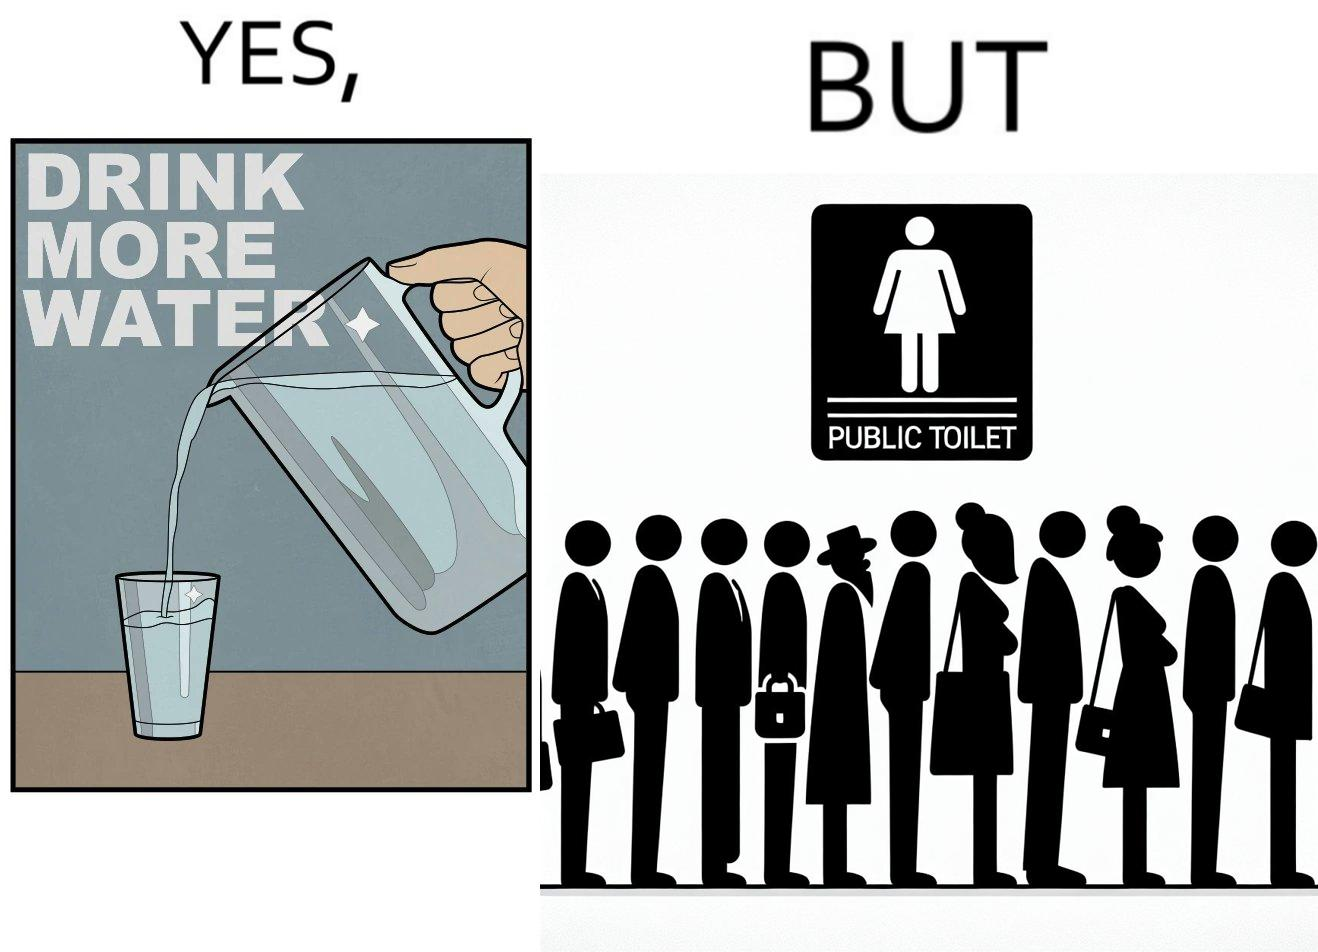Provide a description of this image. The image is ironical, as the message "Drink more water" is meant to improve health, but in turn, it would lead to longer queues in front of public toilets, leading to people holding urine for longer periods, in turn leading to deterioration in health. 